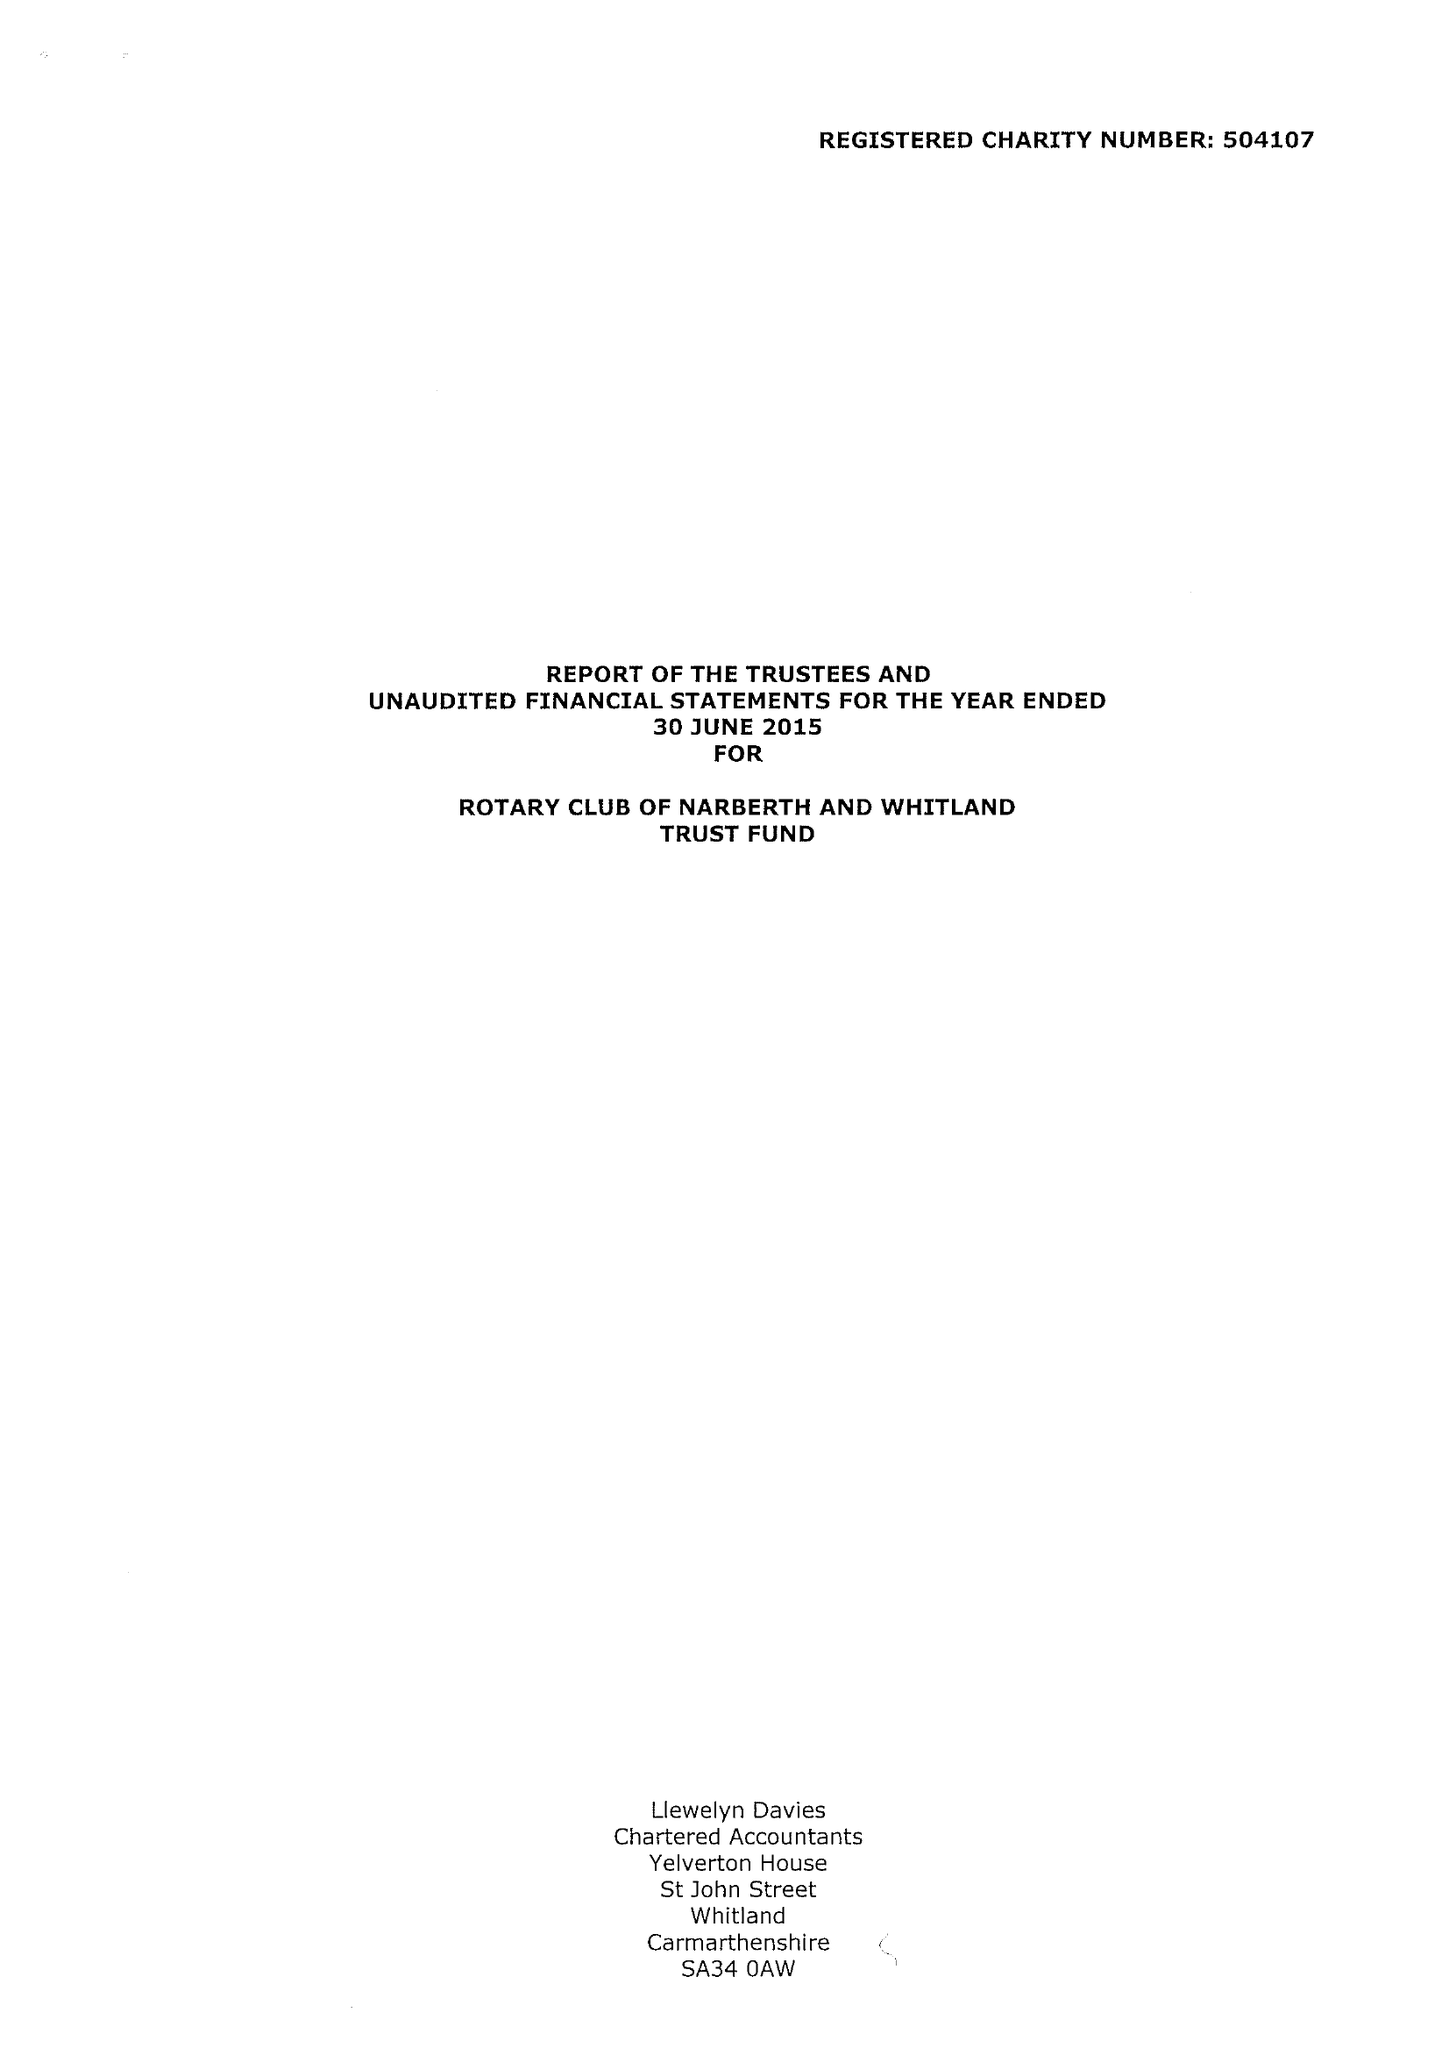What is the value for the charity_number?
Answer the question using a single word or phrase. 504107 